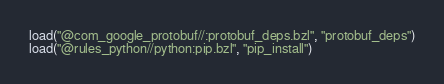Convert code to text. <code><loc_0><loc_0><loc_500><loc_500><_Python_>load("@com_google_protobuf//:protobuf_deps.bzl", "protobuf_deps")
load("@rules_python//python:pip.bzl", "pip_install")</code> 